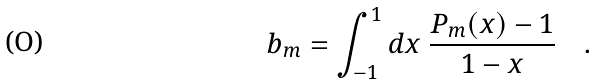Convert formula to latex. <formula><loc_0><loc_0><loc_500><loc_500>b _ { m } = \int _ { - 1 } ^ { 1 } d x \ \frac { P _ { m } ( x ) - 1 } { 1 - x } \quad .</formula> 